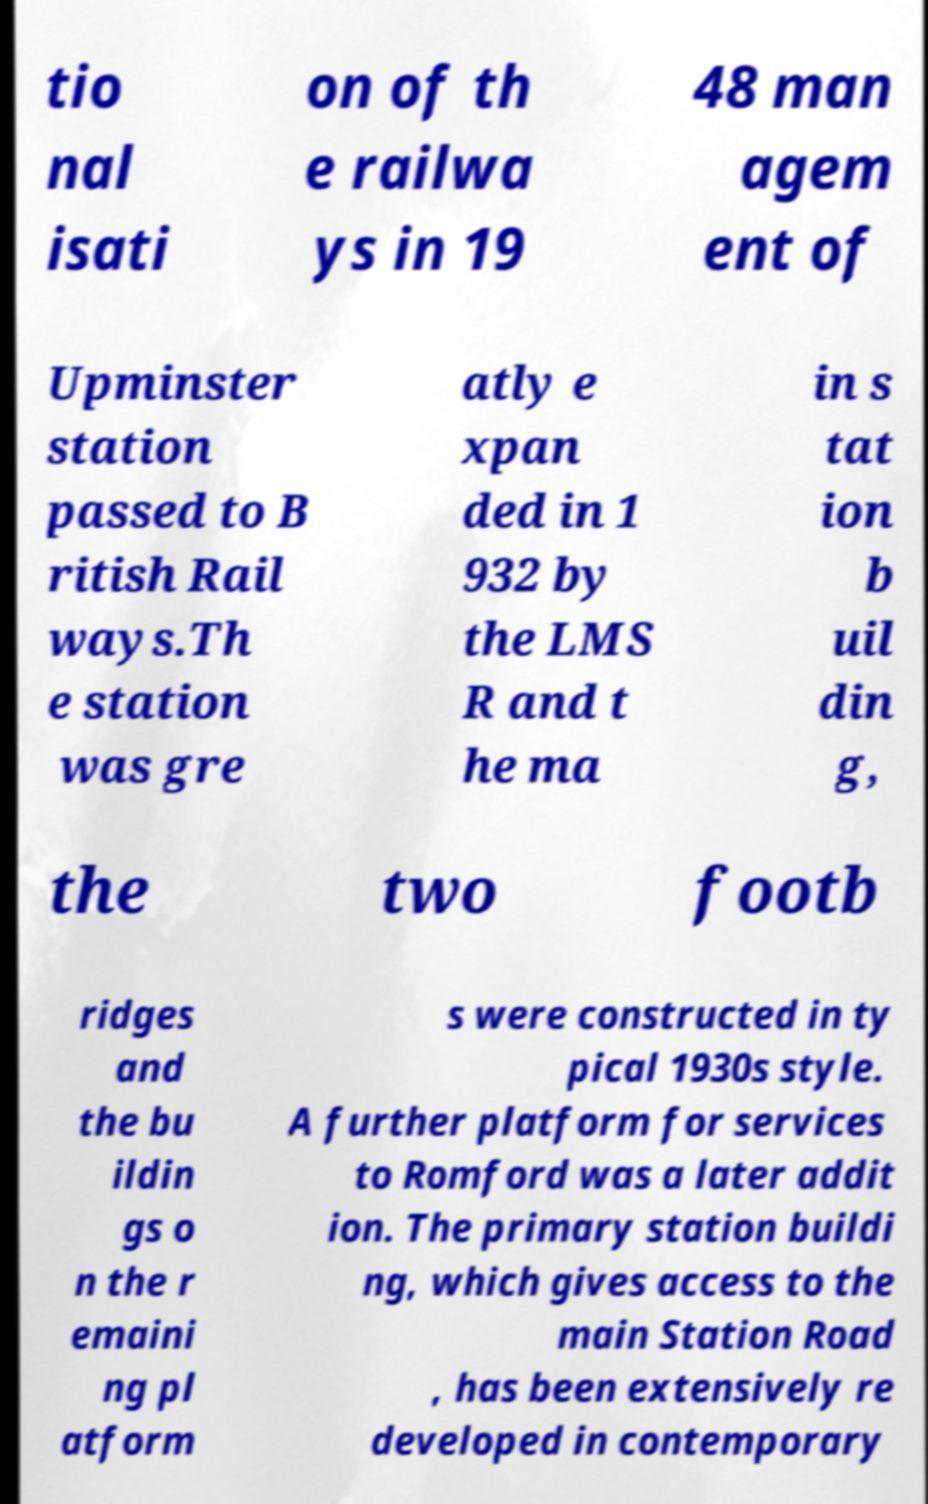Please identify and transcribe the text found in this image. tio nal isati on of th e railwa ys in 19 48 man agem ent of Upminster station passed to B ritish Rail ways.Th e station was gre atly e xpan ded in 1 932 by the LMS R and t he ma in s tat ion b uil din g, the two footb ridges and the bu ildin gs o n the r emaini ng pl atform s were constructed in ty pical 1930s style. A further platform for services to Romford was a later addit ion. The primary station buildi ng, which gives access to the main Station Road , has been extensively re developed in contemporary 